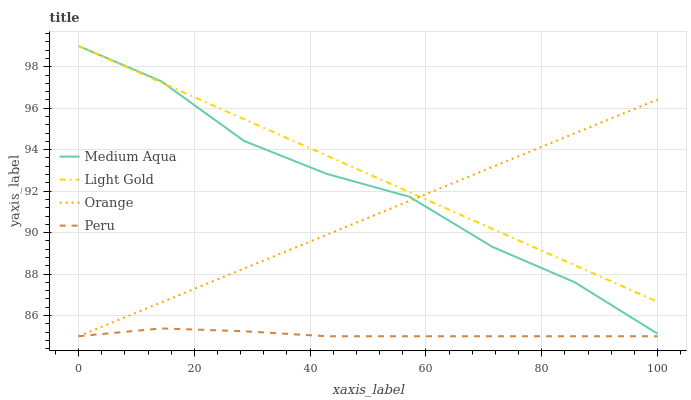Does Medium Aqua have the minimum area under the curve?
Answer yes or no. No. Does Medium Aqua have the maximum area under the curve?
Answer yes or no. No. Is Light Gold the smoothest?
Answer yes or no. No. Is Light Gold the roughest?
Answer yes or no. No. Does Medium Aqua have the lowest value?
Answer yes or no. No. Does Peru have the highest value?
Answer yes or no. No. Is Peru less than Light Gold?
Answer yes or no. Yes. Is Medium Aqua greater than Peru?
Answer yes or no. Yes. Does Peru intersect Light Gold?
Answer yes or no. No. 